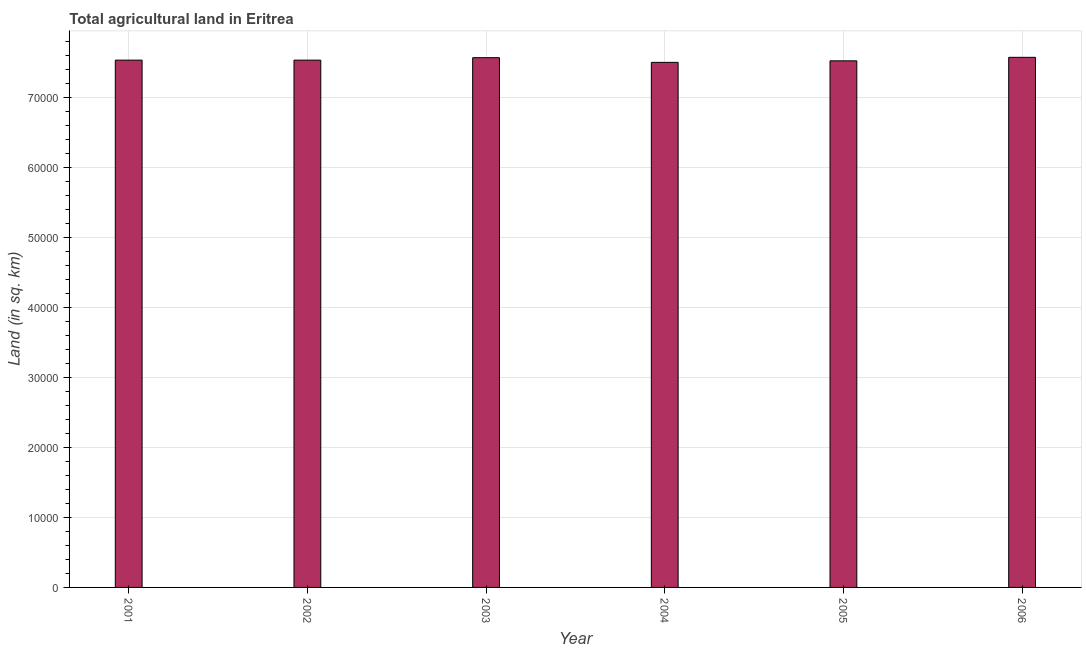What is the title of the graph?
Keep it short and to the point. Total agricultural land in Eritrea. What is the label or title of the Y-axis?
Provide a succinct answer. Land (in sq. km). What is the agricultural land in 2006?
Offer a terse response. 7.57e+04. Across all years, what is the maximum agricultural land?
Give a very brief answer. 7.57e+04. Across all years, what is the minimum agricultural land?
Give a very brief answer. 7.50e+04. What is the sum of the agricultural land?
Give a very brief answer. 4.52e+05. What is the average agricultural land per year?
Keep it short and to the point. 7.54e+04. What is the median agricultural land?
Keep it short and to the point. 7.53e+04. In how many years, is the agricultural land greater than 40000 sq. km?
Provide a short and direct response. 6. What is the ratio of the agricultural land in 2002 to that in 2003?
Your answer should be very brief. 0.99. Is the agricultural land in 2002 less than that in 2005?
Your answer should be compact. No. What is the difference between the highest and the second highest agricultural land?
Provide a short and direct response. 50. Is the sum of the agricultural land in 2002 and 2005 greater than the maximum agricultural land across all years?
Provide a succinct answer. Yes. What is the difference between the highest and the lowest agricultural land?
Give a very brief answer. 720. Are all the bars in the graph horizontal?
Your response must be concise. No. Are the values on the major ticks of Y-axis written in scientific E-notation?
Offer a terse response. No. What is the Land (in sq. km) in 2001?
Make the answer very short. 7.53e+04. What is the Land (in sq. km) in 2002?
Provide a short and direct response. 7.53e+04. What is the Land (in sq. km) in 2003?
Give a very brief answer. 7.57e+04. What is the Land (in sq. km) in 2004?
Ensure brevity in your answer.  7.50e+04. What is the Land (in sq. km) in 2005?
Offer a very short reply. 7.52e+04. What is the Land (in sq. km) of 2006?
Provide a succinct answer. 7.57e+04. What is the difference between the Land (in sq. km) in 2001 and 2002?
Your answer should be compact. 0. What is the difference between the Land (in sq. km) in 2001 and 2003?
Your answer should be compact. -350. What is the difference between the Land (in sq. km) in 2001 and 2004?
Offer a very short reply. 320. What is the difference between the Land (in sq. km) in 2001 and 2005?
Your answer should be very brief. 100. What is the difference between the Land (in sq. km) in 2001 and 2006?
Make the answer very short. -400. What is the difference between the Land (in sq. km) in 2002 and 2003?
Your response must be concise. -350. What is the difference between the Land (in sq. km) in 2002 and 2004?
Provide a succinct answer. 320. What is the difference between the Land (in sq. km) in 2002 and 2005?
Give a very brief answer. 100. What is the difference between the Land (in sq. km) in 2002 and 2006?
Provide a succinct answer. -400. What is the difference between the Land (in sq. km) in 2003 and 2004?
Provide a succinct answer. 670. What is the difference between the Land (in sq. km) in 2003 and 2005?
Give a very brief answer. 450. What is the difference between the Land (in sq. km) in 2004 and 2005?
Your response must be concise. -220. What is the difference between the Land (in sq. km) in 2004 and 2006?
Make the answer very short. -720. What is the difference between the Land (in sq. km) in 2005 and 2006?
Provide a succinct answer. -500. What is the ratio of the Land (in sq. km) in 2001 to that in 2002?
Your answer should be very brief. 1. What is the ratio of the Land (in sq. km) in 2001 to that in 2005?
Keep it short and to the point. 1. What is the ratio of the Land (in sq. km) in 2002 to that in 2003?
Your answer should be very brief. 0.99. What is the ratio of the Land (in sq. km) in 2002 to that in 2004?
Offer a very short reply. 1. What is the ratio of the Land (in sq. km) in 2002 to that in 2005?
Offer a very short reply. 1. What is the ratio of the Land (in sq. km) in 2002 to that in 2006?
Give a very brief answer. 0.99. What is the ratio of the Land (in sq. km) in 2003 to that in 2004?
Your response must be concise. 1.01. What is the ratio of the Land (in sq. km) in 2003 to that in 2005?
Provide a succinct answer. 1.01. What is the ratio of the Land (in sq. km) in 2003 to that in 2006?
Your answer should be compact. 1. What is the ratio of the Land (in sq. km) in 2004 to that in 2006?
Ensure brevity in your answer.  0.99. What is the ratio of the Land (in sq. km) in 2005 to that in 2006?
Offer a terse response. 0.99. 